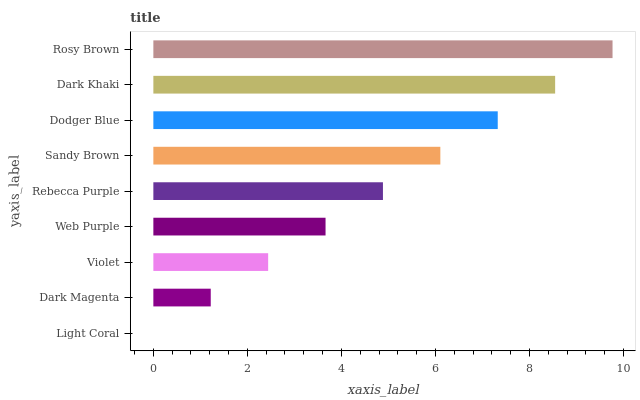Is Light Coral the minimum?
Answer yes or no. Yes. Is Rosy Brown the maximum?
Answer yes or no. Yes. Is Dark Magenta the minimum?
Answer yes or no. No. Is Dark Magenta the maximum?
Answer yes or no. No. Is Dark Magenta greater than Light Coral?
Answer yes or no. Yes. Is Light Coral less than Dark Magenta?
Answer yes or no. Yes. Is Light Coral greater than Dark Magenta?
Answer yes or no. No. Is Dark Magenta less than Light Coral?
Answer yes or no. No. Is Rebecca Purple the high median?
Answer yes or no. Yes. Is Rebecca Purple the low median?
Answer yes or no. Yes. Is Violet the high median?
Answer yes or no. No. Is Dark Magenta the low median?
Answer yes or no. No. 